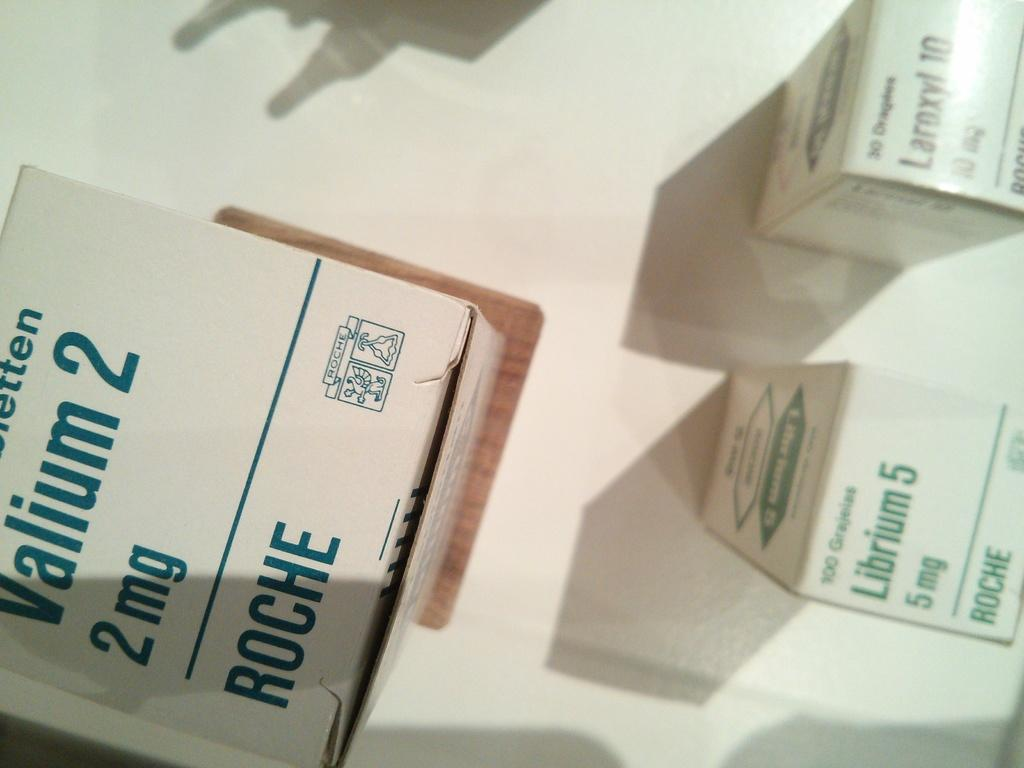<image>
Summarize the visual content of the image. A box containing a 2 mg of Valium 2. 